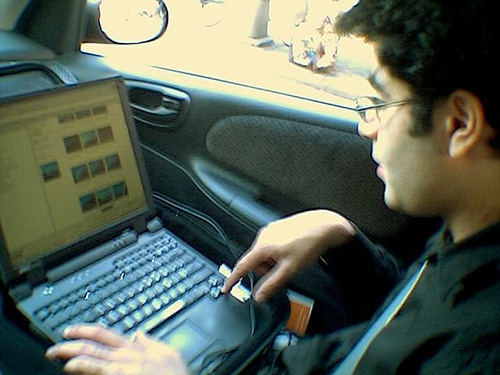Describe the objects in this image and their specific colors. I can see people in teal, black, olive, and beige tones, laptop in teal, olive, darkgreen, and black tones, and tie in teal, lightblue, and blue tones in this image. 